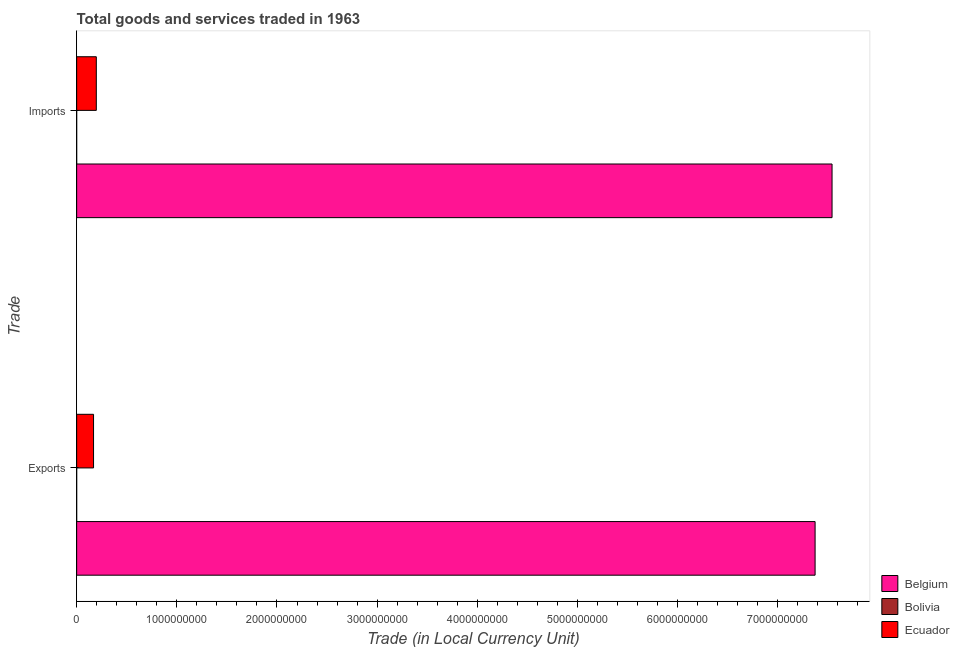How many different coloured bars are there?
Your answer should be compact. 3. How many groups of bars are there?
Your response must be concise. 2. What is the label of the 2nd group of bars from the top?
Ensure brevity in your answer.  Exports. What is the export of goods and services in Ecuador?
Give a very brief answer. 1.69e+08. Across all countries, what is the maximum export of goods and services?
Your answer should be very brief. 7.37e+09. Across all countries, what is the minimum imports of goods and services?
Offer a terse response. 1800. In which country was the imports of goods and services maximum?
Make the answer very short. Belgium. What is the total imports of goods and services in the graph?
Give a very brief answer. 7.74e+09. What is the difference between the imports of goods and services in Bolivia and that in Ecuador?
Offer a terse response. -1.96e+08. What is the difference between the imports of goods and services in Ecuador and the export of goods and services in Belgium?
Your answer should be compact. -7.18e+09. What is the average export of goods and services per country?
Give a very brief answer. 2.51e+09. What is the difference between the export of goods and services and imports of goods and services in Belgium?
Your answer should be compact. -1.69e+08. What is the ratio of the export of goods and services in Belgium to that in Bolivia?
Offer a terse response. 6.14e+06. Is the export of goods and services in Bolivia less than that in Ecuador?
Offer a terse response. Yes. In how many countries, is the export of goods and services greater than the average export of goods and services taken over all countries?
Your answer should be compact. 1. What does the 2nd bar from the bottom in Exports represents?
Give a very brief answer. Bolivia. How many bars are there?
Ensure brevity in your answer.  6. How many countries are there in the graph?
Make the answer very short. 3. What is the difference between two consecutive major ticks on the X-axis?
Provide a short and direct response. 1.00e+09. Are the values on the major ticks of X-axis written in scientific E-notation?
Your answer should be very brief. No. Does the graph contain grids?
Give a very brief answer. No. What is the title of the graph?
Keep it short and to the point. Total goods and services traded in 1963. Does "Bermuda" appear as one of the legend labels in the graph?
Keep it short and to the point. No. What is the label or title of the X-axis?
Your answer should be compact. Trade (in Local Currency Unit). What is the label or title of the Y-axis?
Your answer should be compact. Trade. What is the Trade (in Local Currency Unit) in Belgium in Exports?
Offer a terse response. 7.37e+09. What is the Trade (in Local Currency Unit) in Bolivia in Exports?
Make the answer very short. 1200. What is the Trade (in Local Currency Unit) in Ecuador in Exports?
Your answer should be very brief. 1.69e+08. What is the Trade (in Local Currency Unit) of Belgium in Imports?
Provide a short and direct response. 7.54e+09. What is the Trade (in Local Currency Unit) in Bolivia in Imports?
Keep it short and to the point. 1800. What is the Trade (in Local Currency Unit) in Ecuador in Imports?
Offer a terse response. 1.96e+08. Across all Trade, what is the maximum Trade (in Local Currency Unit) of Belgium?
Provide a short and direct response. 7.54e+09. Across all Trade, what is the maximum Trade (in Local Currency Unit) of Bolivia?
Ensure brevity in your answer.  1800. Across all Trade, what is the maximum Trade (in Local Currency Unit) in Ecuador?
Provide a succinct answer. 1.96e+08. Across all Trade, what is the minimum Trade (in Local Currency Unit) in Belgium?
Your answer should be very brief. 7.37e+09. Across all Trade, what is the minimum Trade (in Local Currency Unit) in Bolivia?
Keep it short and to the point. 1200. Across all Trade, what is the minimum Trade (in Local Currency Unit) in Ecuador?
Your answer should be very brief. 1.69e+08. What is the total Trade (in Local Currency Unit) in Belgium in the graph?
Your answer should be very brief. 1.49e+1. What is the total Trade (in Local Currency Unit) in Bolivia in the graph?
Ensure brevity in your answer.  3000. What is the total Trade (in Local Currency Unit) in Ecuador in the graph?
Provide a succinct answer. 3.65e+08. What is the difference between the Trade (in Local Currency Unit) in Belgium in Exports and that in Imports?
Offer a very short reply. -1.69e+08. What is the difference between the Trade (in Local Currency Unit) of Bolivia in Exports and that in Imports?
Your answer should be compact. -600. What is the difference between the Trade (in Local Currency Unit) of Ecuador in Exports and that in Imports?
Give a very brief answer. -2.76e+07. What is the difference between the Trade (in Local Currency Unit) of Belgium in Exports and the Trade (in Local Currency Unit) of Bolivia in Imports?
Keep it short and to the point. 7.37e+09. What is the difference between the Trade (in Local Currency Unit) in Belgium in Exports and the Trade (in Local Currency Unit) in Ecuador in Imports?
Make the answer very short. 7.18e+09. What is the difference between the Trade (in Local Currency Unit) of Bolivia in Exports and the Trade (in Local Currency Unit) of Ecuador in Imports?
Offer a very short reply. -1.96e+08. What is the average Trade (in Local Currency Unit) of Belgium per Trade?
Your answer should be very brief. 7.46e+09. What is the average Trade (in Local Currency Unit) of Bolivia per Trade?
Provide a succinct answer. 1500. What is the average Trade (in Local Currency Unit) of Ecuador per Trade?
Ensure brevity in your answer.  1.82e+08. What is the difference between the Trade (in Local Currency Unit) of Belgium and Trade (in Local Currency Unit) of Bolivia in Exports?
Your answer should be very brief. 7.37e+09. What is the difference between the Trade (in Local Currency Unit) in Belgium and Trade (in Local Currency Unit) in Ecuador in Exports?
Your answer should be compact. 7.20e+09. What is the difference between the Trade (in Local Currency Unit) in Bolivia and Trade (in Local Currency Unit) in Ecuador in Exports?
Make the answer very short. -1.69e+08. What is the difference between the Trade (in Local Currency Unit) of Belgium and Trade (in Local Currency Unit) of Bolivia in Imports?
Make the answer very short. 7.54e+09. What is the difference between the Trade (in Local Currency Unit) in Belgium and Trade (in Local Currency Unit) in Ecuador in Imports?
Your answer should be very brief. 7.35e+09. What is the difference between the Trade (in Local Currency Unit) in Bolivia and Trade (in Local Currency Unit) in Ecuador in Imports?
Make the answer very short. -1.96e+08. What is the ratio of the Trade (in Local Currency Unit) of Belgium in Exports to that in Imports?
Offer a very short reply. 0.98. What is the ratio of the Trade (in Local Currency Unit) in Ecuador in Exports to that in Imports?
Your answer should be very brief. 0.86. What is the difference between the highest and the second highest Trade (in Local Currency Unit) of Belgium?
Your answer should be very brief. 1.69e+08. What is the difference between the highest and the second highest Trade (in Local Currency Unit) in Bolivia?
Your answer should be compact. 600. What is the difference between the highest and the second highest Trade (in Local Currency Unit) in Ecuador?
Provide a short and direct response. 2.76e+07. What is the difference between the highest and the lowest Trade (in Local Currency Unit) in Belgium?
Ensure brevity in your answer.  1.69e+08. What is the difference between the highest and the lowest Trade (in Local Currency Unit) of Bolivia?
Give a very brief answer. 600. What is the difference between the highest and the lowest Trade (in Local Currency Unit) of Ecuador?
Make the answer very short. 2.76e+07. 